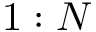Convert formula to latex. <formula><loc_0><loc_0><loc_500><loc_500>1 \colon N</formula> 